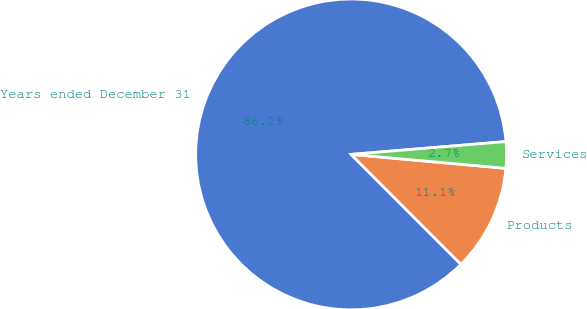<chart> <loc_0><loc_0><loc_500><loc_500><pie_chart><fcel>Years ended December 31<fcel>Products<fcel>Services<nl><fcel>86.18%<fcel>11.08%<fcel>2.74%<nl></chart> 